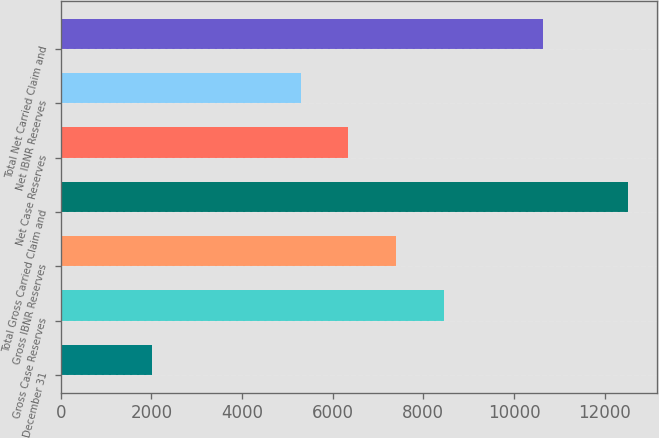Convert chart. <chart><loc_0><loc_0><loc_500><loc_500><bar_chart><fcel>December 31<fcel>Gross Case Reserves<fcel>Gross IBNR Reserves<fcel>Total Gross Carried Claim and<fcel>Net Case Reserves<fcel>Net IBNR Reserves<fcel>Total Net Carried Claim and<nl><fcel>2010<fcel>8445.6<fcel>7394.4<fcel>12522<fcel>6343.2<fcel>5292<fcel>10641<nl></chart> 